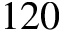Convert formula to latex. <formula><loc_0><loc_0><loc_500><loc_500>1 2 0</formula> 